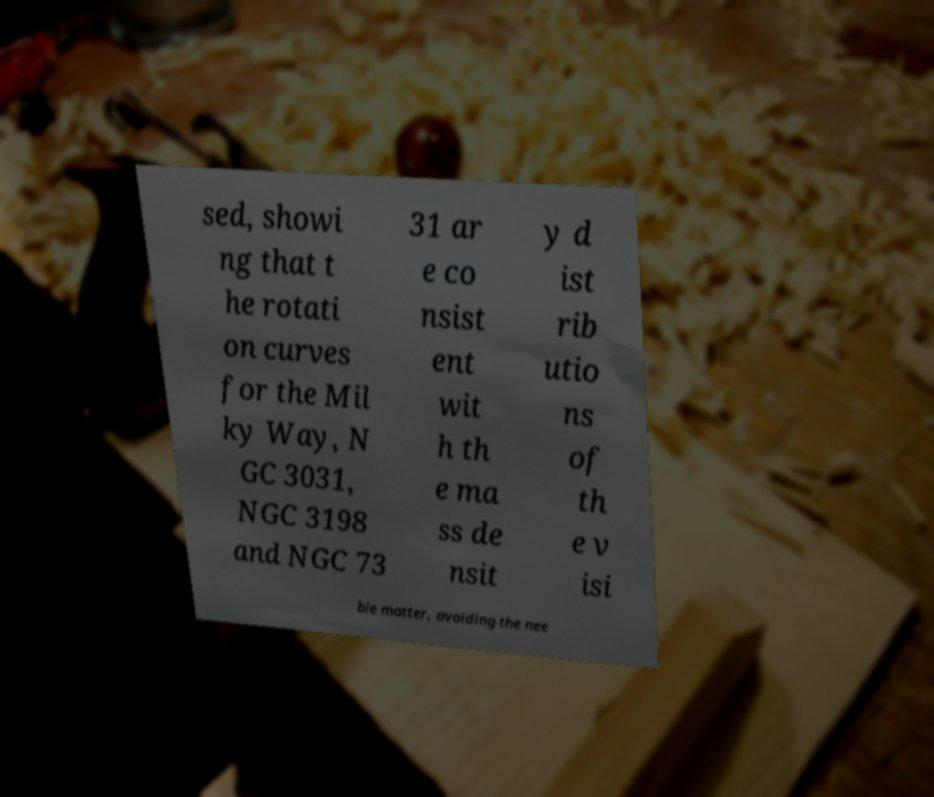Please read and relay the text visible in this image. What does it say? sed, showi ng that t he rotati on curves for the Mil ky Way, N GC 3031, NGC 3198 and NGC 73 31 ar e co nsist ent wit h th e ma ss de nsit y d ist rib utio ns of th e v isi ble matter, avoiding the nee 